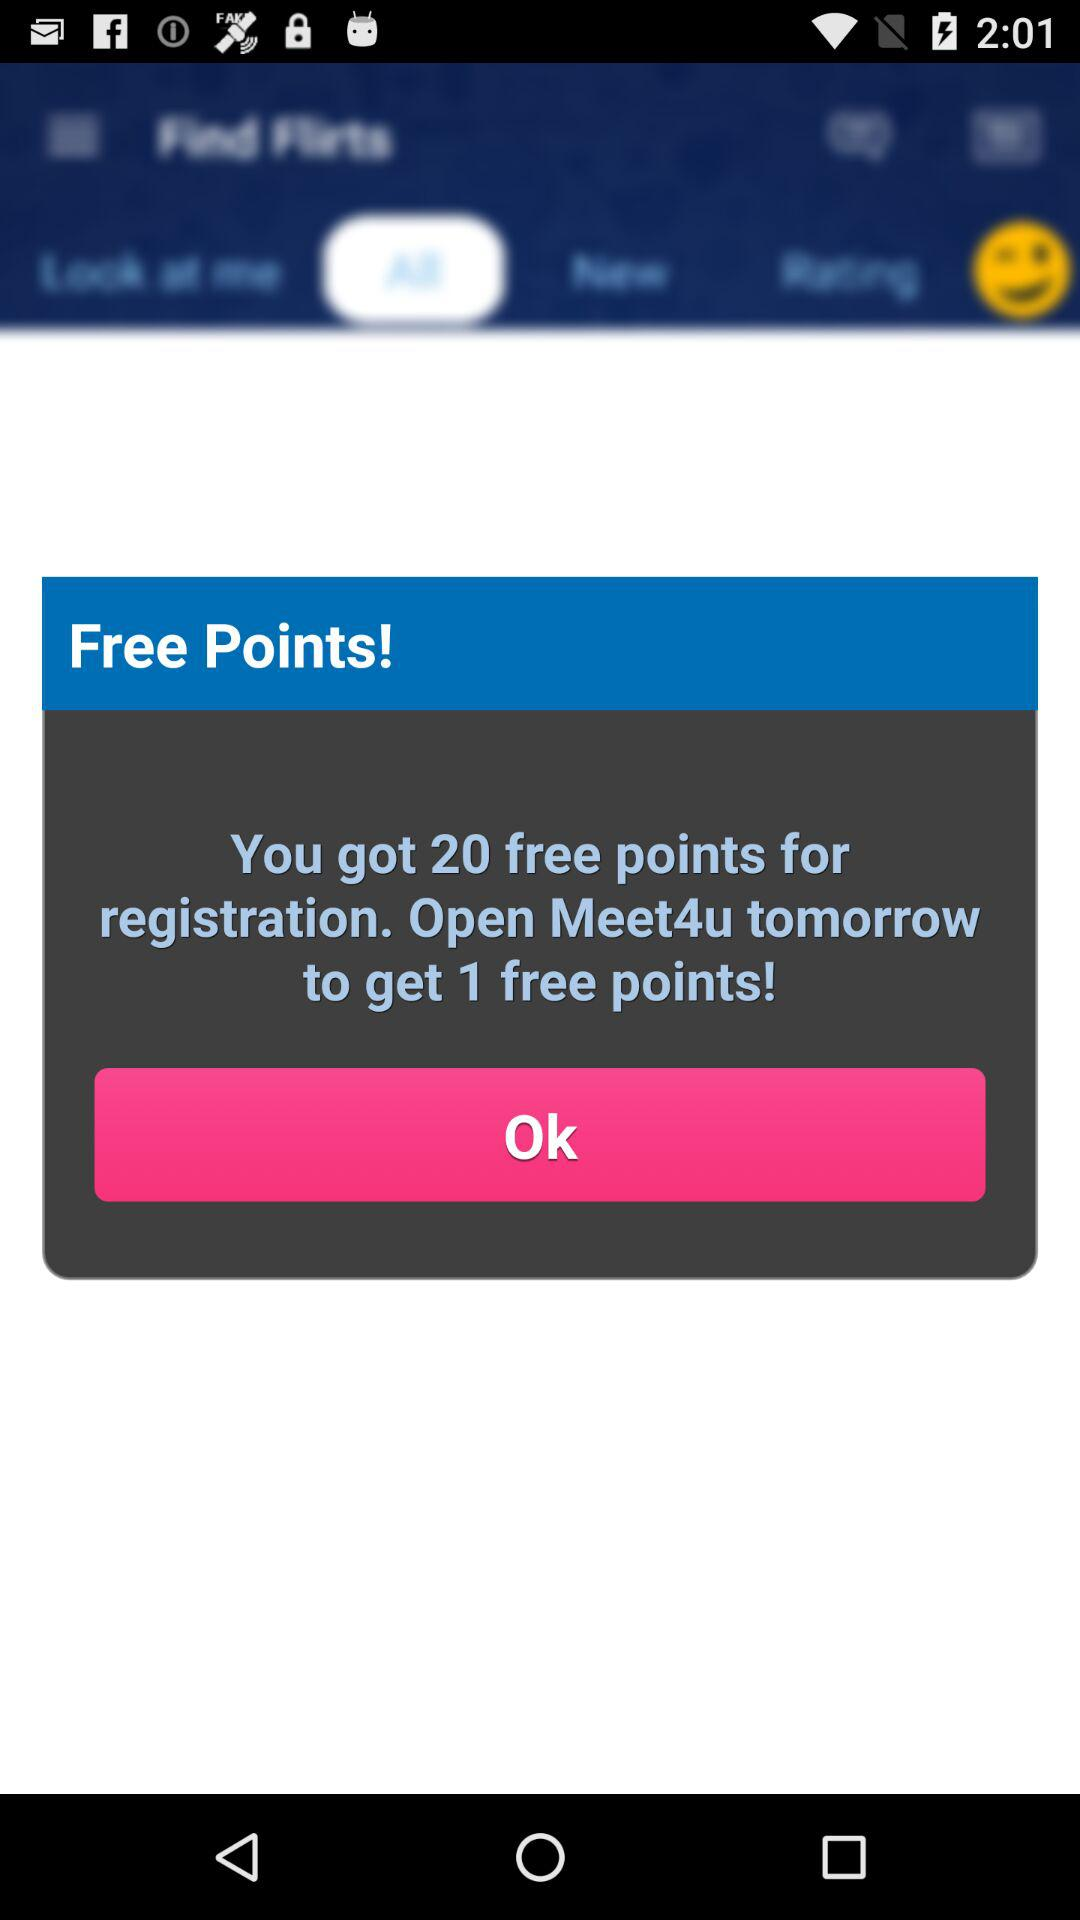How many free points will I have in total if I open Meet4u tomorrow?
Answer the question using a single word or phrase. 21 